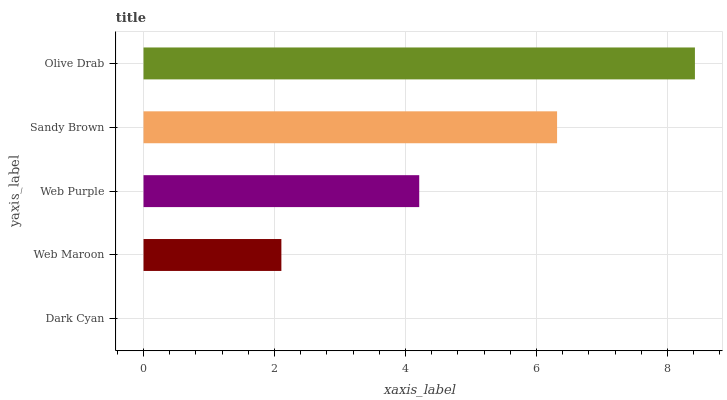Is Dark Cyan the minimum?
Answer yes or no. Yes. Is Olive Drab the maximum?
Answer yes or no. Yes. Is Web Maroon the minimum?
Answer yes or no. No. Is Web Maroon the maximum?
Answer yes or no. No. Is Web Maroon greater than Dark Cyan?
Answer yes or no. Yes. Is Dark Cyan less than Web Maroon?
Answer yes or no. Yes. Is Dark Cyan greater than Web Maroon?
Answer yes or no. No. Is Web Maroon less than Dark Cyan?
Answer yes or no. No. Is Web Purple the high median?
Answer yes or no. Yes. Is Web Purple the low median?
Answer yes or no. Yes. Is Web Maroon the high median?
Answer yes or no. No. Is Dark Cyan the low median?
Answer yes or no. No. 